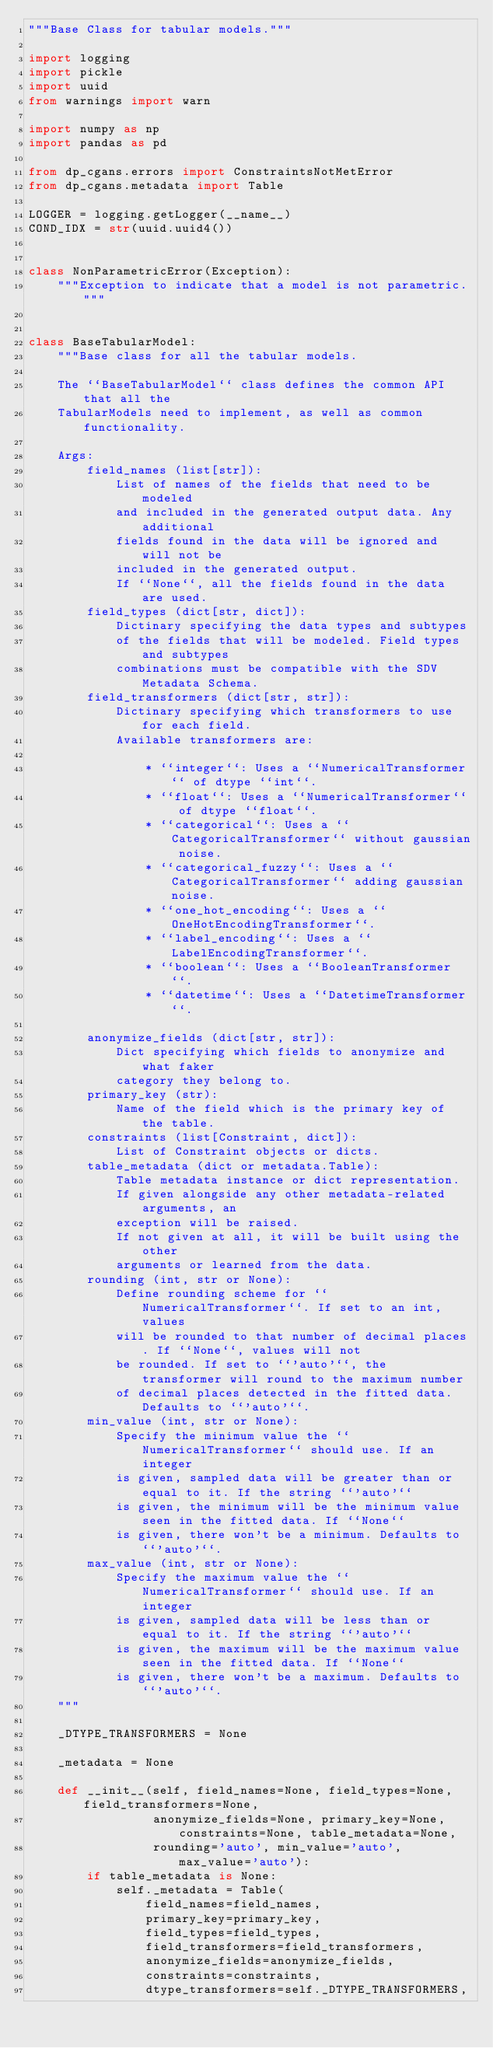<code> <loc_0><loc_0><loc_500><loc_500><_Python_>"""Base Class for tabular models."""

import logging
import pickle
import uuid
from warnings import warn

import numpy as np
import pandas as pd

from dp_cgans.errors import ConstraintsNotMetError
from dp_cgans.metadata import Table

LOGGER = logging.getLogger(__name__)
COND_IDX = str(uuid.uuid4())


class NonParametricError(Exception):
    """Exception to indicate that a model is not parametric."""


class BaseTabularModel:
    """Base class for all the tabular models.

    The ``BaseTabularModel`` class defines the common API that all the
    TabularModels need to implement, as well as common functionality.

    Args:
        field_names (list[str]):
            List of names of the fields that need to be modeled
            and included in the generated output data. Any additional
            fields found in the data will be ignored and will not be
            included in the generated output.
            If ``None``, all the fields found in the data are used.
        field_types (dict[str, dict]):
            Dictinary specifying the data types and subtypes
            of the fields that will be modeled. Field types and subtypes
            combinations must be compatible with the SDV Metadata Schema.
        field_transformers (dict[str, str]):
            Dictinary specifying which transformers to use for each field.
            Available transformers are:

                * ``integer``: Uses a ``NumericalTransformer`` of dtype ``int``.
                * ``float``: Uses a ``NumericalTransformer`` of dtype ``float``.
                * ``categorical``: Uses a ``CategoricalTransformer`` without gaussian noise.
                * ``categorical_fuzzy``: Uses a ``CategoricalTransformer`` adding gaussian noise.
                * ``one_hot_encoding``: Uses a ``OneHotEncodingTransformer``.
                * ``label_encoding``: Uses a ``LabelEncodingTransformer``.
                * ``boolean``: Uses a ``BooleanTransformer``.
                * ``datetime``: Uses a ``DatetimeTransformer``.

        anonymize_fields (dict[str, str]):
            Dict specifying which fields to anonymize and what faker
            category they belong to.
        primary_key (str):
            Name of the field which is the primary key of the table.
        constraints (list[Constraint, dict]):
            List of Constraint objects or dicts.
        table_metadata (dict or metadata.Table):
            Table metadata instance or dict representation.
            If given alongside any other metadata-related arguments, an
            exception will be raised.
            If not given at all, it will be built using the other
            arguments or learned from the data.
        rounding (int, str or None):
            Define rounding scheme for ``NumericalTransformer``. If set to an int, values
            will be rounded to that number of decimal places. If ``None``, values will not
            be rounded. If set to ``'auto'``, the transformer will round to the maximum number
            of decimal places detected in the fitted data. Defaults to ``'auto'``.
        min_value (int, str or None):
            Specify the minimum value the ``NumericalTransformer`` should use. If an integer
            is given, sampled data will be greater than or equal to it. If the string ``'auto'``
            is given, the minimum will be the minimum value seen in the fitted data. If ``None``
            is given, there won't be a minimum. Defaults to ``'auto'``.
        max_value (int, str or None):
            Specify the maximum value the ``NumericalTransformer`` should use. If an integer
            is given, sampled data will be less than or equal to it. If the string ``'auto'``
            is given, the maximum will be the maximum value seen in the fitted data. If ``None``
            is given, there won't be a maximum. Defaults to ``'auto'``.
    """

    _DTYPE_TRANSFORMERS = None

    _metadata = None

    def __init__(self, field_names=None, field_types=None, field_transformers=None,
                 anonymize_fields=None, primary_key=None, constraints=None, table_metadata=None,
                 rounding='auto', min_value='auto', max_value='auto'):
        if table_metadata is None:
            self._metadata = Table(
                field_names=field_names,
                primary_key=primary_key,
                field_types=field_types,
                field_transformers=field_transformers,
                anonymize_fields=anonymize_fields,
                constraints=constraints,
                dtype_transformers=self._DTYPE_TRANSFORMERS,</code> 